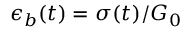<formula> <loc_0><loc_0><loc_500><loc_500>\epsilon _ { b } ( t ) = \sigma ( t ) / G _ { 0 }</formula> 